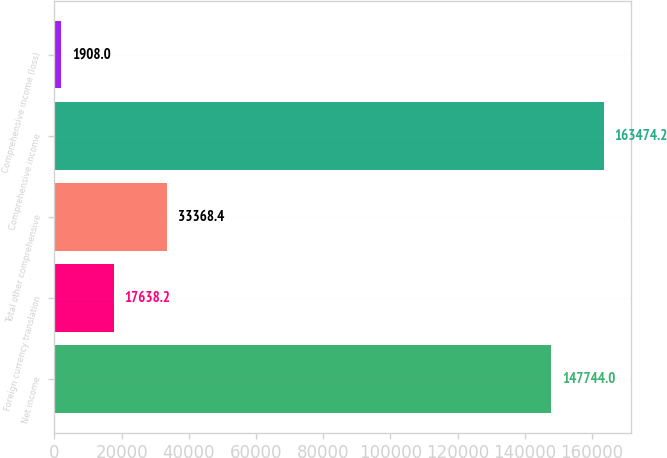<chart> <loc_0><loc_0><loc_500><loc_500><bar_chart><fcel>Net income<fcel>Foreign currency translation<fcel>Total other comprehensive<fcel>Comprehensive income<fcel>Comprehensive income (loss)<nl><fcel>147744<fcel>17638.2<fcel>33368.4<fcel>163474<fcel>1908<nl></chart> 